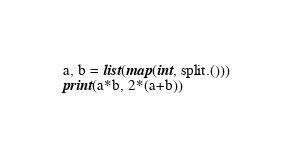Convert code to text. <code><loc_0><loc_0><loc_500><loc_500><_Python_>a, b = list(map(int, split.()))
print(a*b, 2*(a+b))</code> 